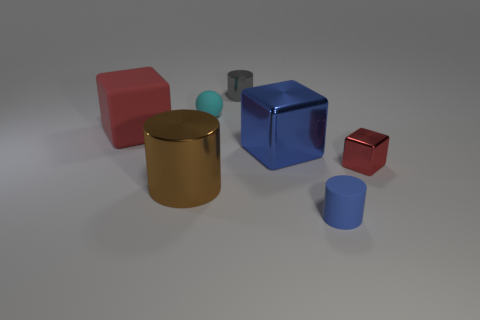How many tiny matte cylinders are the same color as the big metal cube?
Ensure brevity in your answer.  1. There is a thing that is both right of the large blue cube and on the left side of the small red thing; what shape is it?
Give a very brief answer. Cylinder. What is the big object on the right side of the large shiny thing in front of the metallic object that is to the right of the blue matte thing made of?
Your answer should be compact. Metal. Are there more big blue shiny cubes that are in front of the large brown metallic object than tiny gray metal things in front of the small cyan object?
Make the answer very short. No. What number of tiny blocks are made of the same material as the tiny ball?
Make the answer very short. 0. Does the small matte thing in front of the red rubber object have the same shape as the large thing on the left side of the big cylinder?
Your answer should be very brief. No. There is a cube that is to the right of the small blue matte cylinder; what is its color?
Provide a succinct answer. Red. Are there any large gray rubber things that have the same shape as the cyan rubber object?
Provide a short and direct response. No. What is the large blue block made of?
Make the answer very short. Metal. What is the size of the cylinder that is both to the right of the large brown cylinder and on the left side of the small blue cylinder?
Offer a very short reply. Small. 